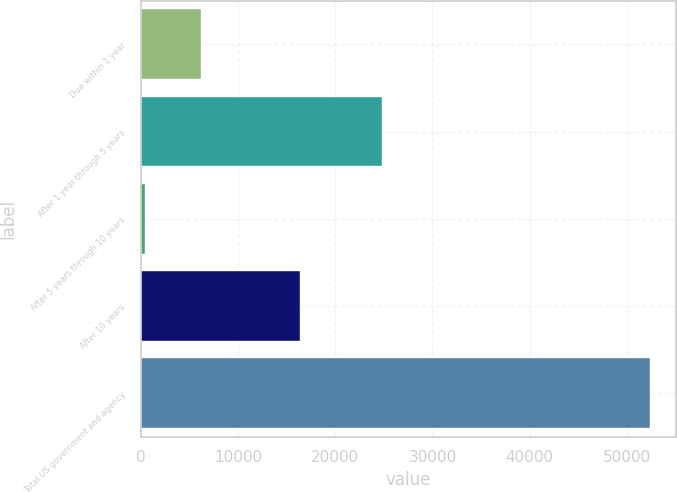<chart> <loc_0><loc_0><loc_500><loc_500><bar_chart><fcel>Due within 1 year<fcel>After 1 year through 5 years<fcel>After 5 years through 10 years<fcel>After 10 years<fcel>Total US government and agency<nl><fcel>6205<fcel>24765<fcel>447<fcel>16342<fcel>52393<nl></chart> 